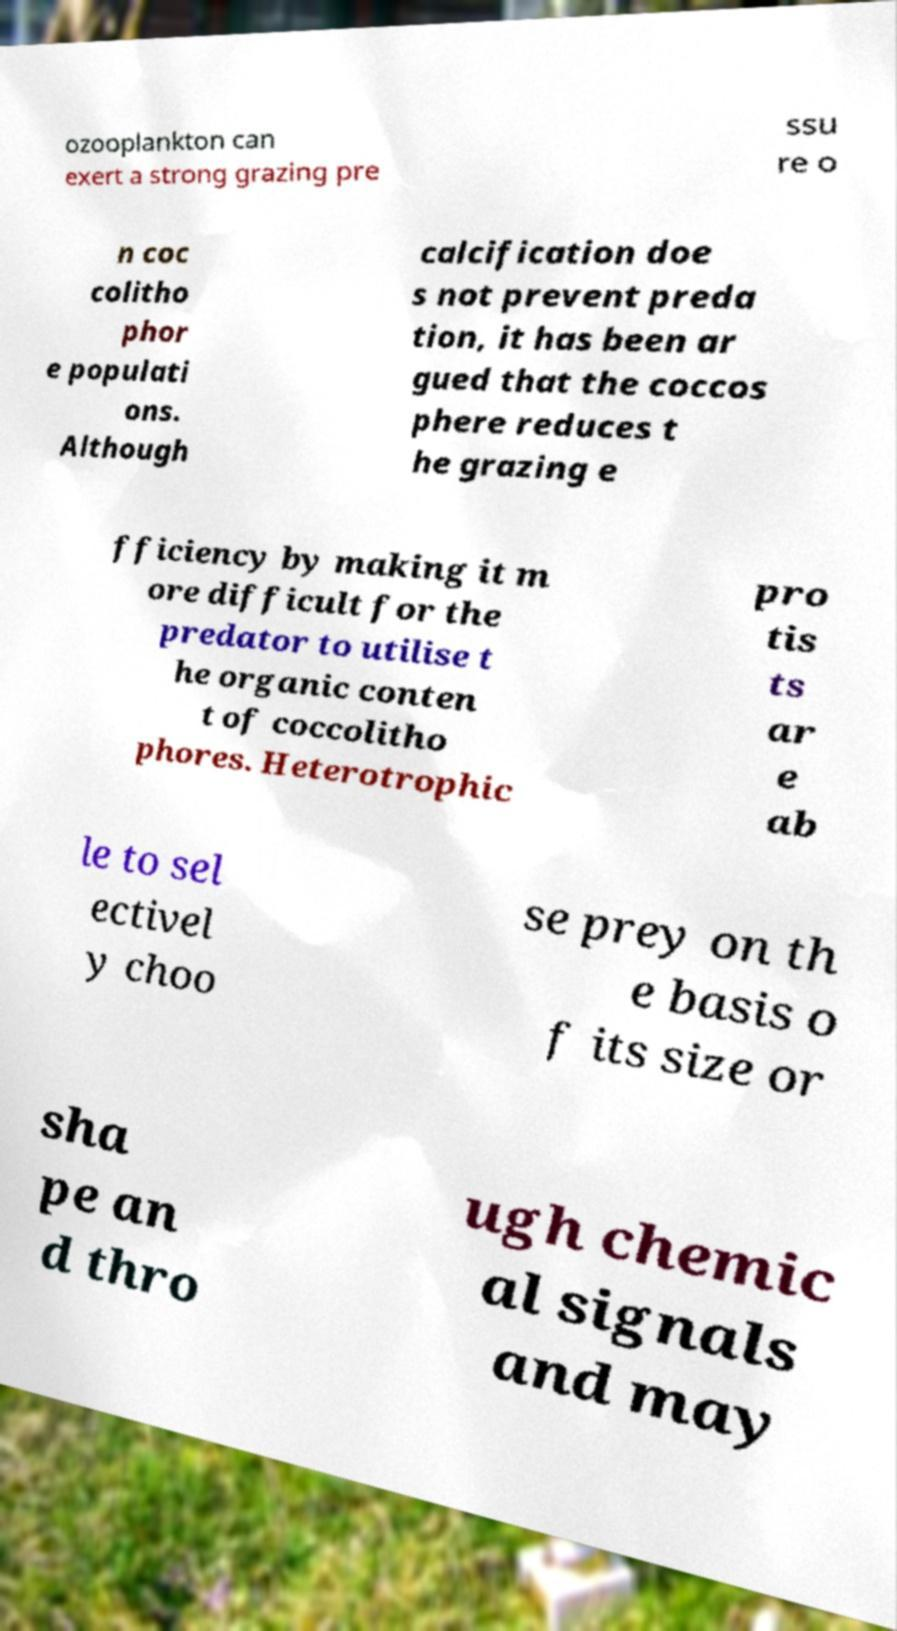Please read and relay the text visible in this image. What does it say? ozooplankton can exert a strong grazing pre ssu re o n coc colitho phor e populati ons. Although calcification doe s not prevent preda tion, it has been ar gued that the coccos phere reduces t he grazing e fficiency by making it m ore difficult for the predator to utilise t he organic conten t of coccolitho phores. Heterotrophic pro tis ts ar e ab le to sel ectivel y choo se prey on th e basis o f its size or sha pe an d thro ugh chemic al signals and may 